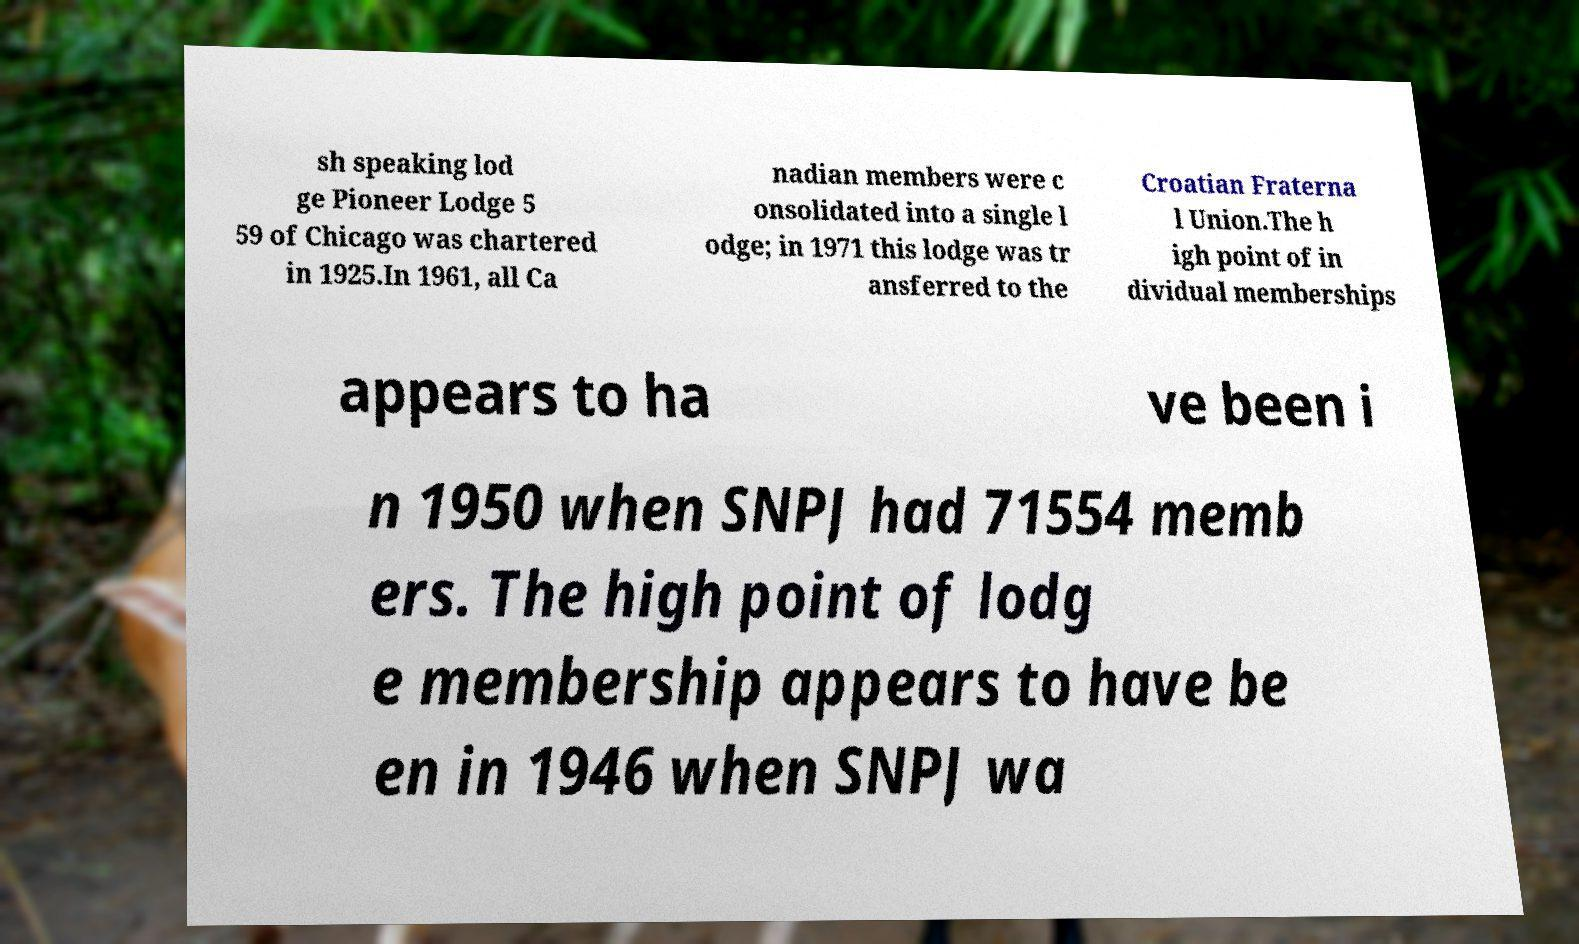Can you accurately transcribe the text from the provided image for me? sh speaking lod ge Pioneer Lodge 5 59 of Chicago was chartered in 1925.In 1961, all Ca nadian members were c onsolidated into a single l odge; in 1971 this lodge was tr ansferred to the Croatian Fraterna l Union.The h igh point of in dividual memberships appears to ha ve been i n 1950 when SNPJ had 71554 memb ers. The high point of lodg e membership appears to have be en in 1946 when SNPJ wa 